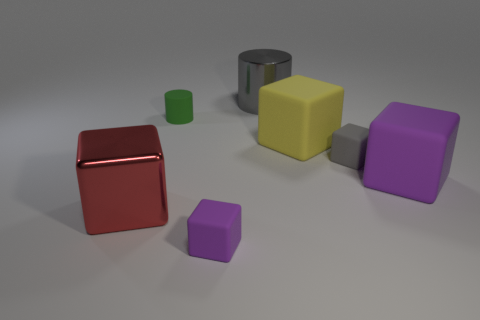There is a small cube that is behind the big purple matte cube; does it have the same color as the large cylinder?
Offer a very short reply. Yes. There is a gray object that is on the left side of the yellow object; is it the same size as the green matte cylinder?
Provide a succinct answer. No. Is there a rubber cube of the same color as the big metallic cylinder?
Your answer should be very brief. Yes. There is a purple block that is left of the gray cylinder behind the purple matte thing that is on the left side of the gray rubber thing; how big is it?
Provide a short and direct response. Small. There is a large yellow thing that is the same shape as the red shiny object; what is it made of?
Provide a short and direct response. Rubber. There is a small cube that is in front of the small gray rubber block to the right of the tiny cylinder; are there any gray matte objects that are behind it?
Give a very brief answer. Yes. There is a purple thing to the left of the large purple rubber cube; does it have the same shape as the metallic object that is on the left side of the tiny cylinder?
Make the answer very short. Yes. Is the number of objects that are to the right of the shiny cylinder greater than the number of purple rubber things?
Your response must be concise. Yes. How many objects are either tiny metallic balls or big metal cylinders?
Offer a terse response. 1. What color is the matte cylinder?
Your response must be concise. Green. 